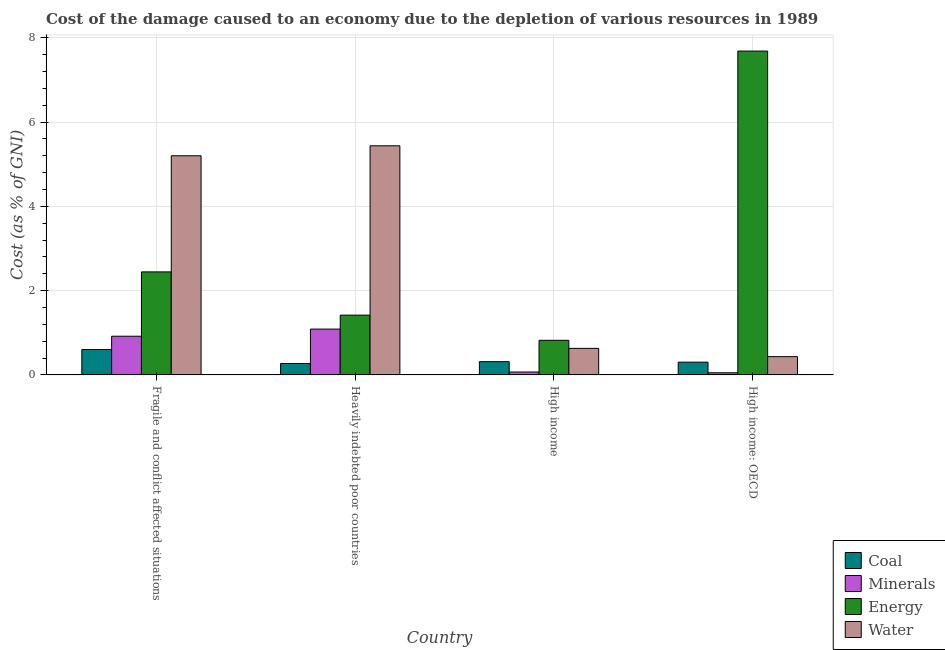How many groups of bars are there?
Provide a short and direct response. 4. Are the number of bars per tick equal to the number of legend labels?
Your answer should be very brief. Yes. Are the number of bars on each tick of the X-axis equal?
Provide a short and direct response. Yes. How many bars are there on the 2nd tick from the left?
Your answer should be very brief. 4. What is the cost of damage due to depletion of water in High income?
Your answer should be very brief. 0.63. Across all countries, what is the maximum cost of damage due to depletion of minerals?
Keep it short and to the point. 1.09. Across all countries, what is the minimum cost of damage due to depletion of coal?
Provide a short and direct response. 0.27. In which country was the cost of damage due to depletion of water maximum?
Ensure brevity in your answer.  Heavily indebted poor countries. In which country was the cost of damage due to depletion of coal minimum?
Your answer should be compact. Heavily indebted poor countries. What is the total cost of damage due to depletion of coal in the graph?
Provide a succinct answer. 1.49. What is the difference between the cost of damage due to depletion of energy in High income and that in High income: OECD?
Your answer should be compact. -6.86. What is the difference between the cost of damage due to depletion of coal in Heavily indebted poor countries and the cost of damage due to depletion of water in Fragile and conflict affected situations?
Your response must be concise. -4.93. What is the average cost of damage due to depletion of energy per country?
Provide a succinct answer. 3.09. What is the difference between the cost of damage due to depletion of water and cost of damage due to depletion of minerals in High income: OECD?
Offer a terse response. 0.38. In how many countries, is the cost of damage due to depletion of water greater than 4.4 %?
Offer a very short reply. 2. What is the ratio of the cost of damage due to depletion of minerals in Fragile and conflict affected situations to that in High income?
Your response must be concise. 13.32. Is the difference between the cost of damage due to depletion of minerals in Fragile and conflict affected situations and High income: OECD greater than the difference between the cost of damage due to depletion of energy in Fragile and conflict affected situations and High income: OECD?
Offer a very short reply. Yes. What is the difference between the highest and the second highest cost of damage due to depletion of energy?
Keep it short and to the point. 5.24. What is the difference between the highest and the lowest cost of damage due to depletion of water?
Your answer should be very brief. 5. Is the sum of the cost of damage due to depletion of energy in Fragile and conflict affected situations and High income greater than the maximum cost of damage due to depletion of minerals across all countries?
Ensure brevity in your answer.  Yes. What does the 2nd bar from the left in Fragile and conflict affected situations represents?
Keep it short and to the point. Minerals. What does the 3rd bar from the right in High income represents?
Your answer should be compact. Minerals. How many bars are there?
Offer a terse response. 16. Are all the bars in the graph horizontal?
Offer a terse response. No. How many countries are there in the graph?
Make the answer very short. 4. What is the difference between two consecutive major ticks on the Y-axis?
Make the answer very short. 2. Does the graph contain grids?
Provide a short and direct response. Yes. Where does the legend appear in the graph?
Keep it short and to the point. Bottom right. How are the legend labels stacked?
Ensure brevity in your answer.  Vertical. What is the title of the graph?
Provide a succinct answer. Cost of the damage caused to an economy due to the depletion of various resources in 1989 . What is the label or title of the X-axis?
Give a very brief answer. Country. What is the label or title of the Y-axis?
Provide a short and direct response. Cost (as % of GNI). What is the Cost (as % of GNI) in Coal in Fragile and conflict affected situations?
Your answer should be compact. 0.6. What is the Cost (as % of GNI) in Minerals in Fragile and conflict affected situations?
Offer a terse response. 0.92. What is the Cost (as % of GNI) of Energy in Fragile and conflict affected situations?
Provide a short and direct response. 2.44. What is the Cost (as % of GNI) in Water in Fragile and conflict affected situations?
Your answer should be very brief. 5.2. What is the Cost (as % of GNI) in Coal in Heavily indebted poor countries?
Your answer should be compact. 0.27. What is the Cost (as % of GNI) of Minerals in Heavily indebted poor countries?
Provide a succinct answer. 1.09. What is the Cost (as % of GNI) of Energy in Heavily indebted poor countries?
Your answer should be very brief. 1.42. What is the Cost (as % of GNI) in Water in Heavily indebted poor countries?
Your answer should be very brief. 5.44. What is the Cost (as % of GNI) in Coal in High income?
Give a very brief answer. 0.31. What is the Cost (as % of GNI) in Minerals in High income?
Ensure brevity in your answer.  0.07. What is the Cost (as % of GNI) of Energy in High income?
Offer a very short reply. 0.82. What is the Cost (as % of GNI) in Water in High income?
Your response must be concise. 0.63. What is the Cost (as % of GNI) in Coal in High income: OECD?
Make the answer very short. 0.3. What is the Cost (as % of GNI) of Minerals in High income: OECD?
Offer a terse response. 0.05. What is the Cost (as % of GNI) of Energy in High income: OECD?
Provide a succinct answer. 7.68. What is the Cost (as % of GNI) in Water in High income: OECD?
Your answer should be compact. 0.43. Across all countries, what is the maximum Cost (as % of GNI) in Coal?
Give a very brief answer. 0.6. Across all countries, what is the maximum Cost (as % of GNI) in Minerals?
Offer a terse response. 1.09. Across all countries, what is the maximum Cost (as % of GNI) of Energy?
Provide a short and direct response. 7.68. Across all countries, what is the maximum Cost (as % of GNI) in Water?
Provide a succinct answer. 5.44. Across all countries, what is the minimum Cost (as % of GNI) in Coal?
Keep it short and to the point. 0.27. Across all countries, what is the minimum Cost (as % of GNI) in Minerals?
Give a very brief answer. 0.05. Across all countries, what is the minimum Cost (as % of GNI) in Energy?
Make the answer very short. 0.82. Across all countries, what is the minimum Cost (as % of GNI) in Water?
Ensure brevity in your answer.  0.43. What is the total Cost (as % of GNI) in Coal in the graph?
Offer a very short reply. 1.49. What is the total Cost (as % of GNI) in Minerals in the graph?
Provide a short and direct response. 2.12. What is the total Cost (as % of GNI) of Energy in the graph?
Ensure brevity in your answer.  12.37. What is the total Cost (as % of GNI) of Water in the graph?
Offer a terse response. 11.7. What is the difference between the Cost (as % of GNI) in Coal in Fragile and conflict affected situations and that in Heavily indebted poor countries?
Keep it short and to the point. 0.33. What is the difference between the Cost (as % of GNI) in Minerals in Fragile and conflict affected situations and that in Heavily indebted poor countries?
Offer a terse response. -0.17. What is the difference between the Cost (as % of GNI) in Energy in Fragile and conflict affected situations and that in Heavily indebted poor countries?
Your response must be concise. 1.03. What is the difference between the Cost (as % of GNI) in Water in Fragile and conflict affected situations and that in Heavily indebted poor countries?
Offer a terse response. -0.24. What is the difference between the Cost (as % of GNI) in Coal in Fragile and conflict affected situations and that in High income?
Your response must be concise. 0.29. What is the difference between the Cost (as % of GNI) in Minerals in Fragile and conflict affected situations and that in High income?
Offer a very short reply. 0.85. What is the difference between the Cost (as % of GNI) in Energy in Fragile and conflict affected situations and that in High income?
Your answer should be compact. 1.62. What is the difference between the Cost (as % of GNI) of Water in Fragile and conflict affected situations and that in High income?
Ensure brevity in your answer.  4.57. What is the difference between the Cost (as % of GNI) in Coal in Fragile and conflict affected situations and that in High income: OECD?
Make the answer very short. 0.3. What is the difference between the Cost (as % of GNI) of Minerals in Fragile and conflict affected situations and that in High income: OECD?
Ensure brevity in your answer.  0.87. What is the difference between the Cost (as % of GNI) in Energy in Fragile and conflict affected situations and that in High income: OECD?
Provide a succinct answer. -5.24. What is the difference between the Cost (as % of GNI) in Water in Fragile and conflict affected situations and that in High income: OECD?
Provide a short and direct response. 4.77. What is the difference between the Cost (as % of GNI) of Coal in Heavily indebted poor countries and that in High income?
Provide a succinct answer. -0.04. What is the difference between the Cost (as % of GNI) in Minerals in Heavily indebted poor countries and that in High income?
Offer a terse response. 1.02. What is the difference between the Cost (as % of GNI) of Energy in Heavily indebted poor countries and that in High income?
Give a very brief answer. 0.6. What is the difference between the Cost (as % of GNI) in Water in Heavily indebted poor countries and that in High income?
Keep it short and to the point. 4.81. What is the difference between the Cost (as % of GNI) of Coal in Heavily indebted poor countries and that in High income: OECD?
Ensure brevity in your answer.  -0.03. What is the difference between the Cost (as % of GNI) of Minerals in Heavily indebted poor countries and that in High income: OECD?
Make the answer very short. 1.04. What is the difference between the Cost (as % of GNI) in Energy in Heavily indebted poor countries and that in High income: OECD?
Provide a short and direct response. -6.26. What is the difference between the Cost (as % of GNI) in Water in Heavily indebted poor countries and that in High income: OECD?
Ensure brevity in your answer.  5. What is the difference between the Cost (as % of GNI) in Coal in High income and that in High income: OECD?
Offer a terse response. 0.01. What is the difference between the Cost (as % of GNI) of Minerals in High income and that in High income: OECD?
Offer a very short reply. 0.02. What is the difference between the Cost (as % of GNI) of Energy in High income and that in High income: OECD?
Your answer should be compact. -6.86. What is the difference between the Cost (as % of GNI) in Water in High income and that in High income: OECD?
Give a very brief answer. 0.2. What is the difference between the Cost (as % of GNI) in Coal in Fragile and conflict affected situations and the Cost (as % of GNI) in Minerals in Heavily indebted poor countries?
Your answer should be very brief. -0.48. What is the difference between the Cost (as % of GNI) in Coal in Fragile and conflict affected situations and the Cost (as % of GNI) in Energy in Heavily indebted poor countries?
Provide a succinct answer. -0.82. What is the difference between the Cost (as % of GNI) of Coal in Fragile and conflict affected situations and the Cost (as % of GNI) of Water in Heavily indebted poor countries?
Keep it short and to the point. -4.83. What is the difference between the Cost (as % of GNI) in Minerals in Fragile and conflict affected situations and the Cost (as % of GNI) in Energy in Heavily indebted poor countries?
Offer a terse response. -0.5. What is the difference between the Cost (as % of GNI) in Minerals in Fragile and conflict affected situations and the Cost (as % of GNI) in Water in Heavily indebted poor countries?
Offer a very short reply. -4.52. What is the difference between the Cost (as % of GNI) in Energy in Fragile and conflict affected situations and the Cost (as % of GNI) in Water in Heavily indebted poor countries?
Offer a terse response. -2.99. What is the difference between the Cost (as % of GNI) of Coal in Fragile and conflict affected situations and the Cost (as % of GNI) of Minerals in High income?
Your answer should be very brief. 0.53. What is the difference between the Cost (as % of GNI) of Coal in Fragile and conflict affected situations and the Cost (as % of GNI) of Energy in High income?
Make the answer very short. -0.22. What is the difference between the Cost (as % of GNI) in Coal in Fragile and conflict affected situations and the Cost (as % of GNI) in Water in High income?
Offer a terse response. -0.03. What is the difference between the Cost (as % of GNI) in Minerals in Fragile and conflict affected situations and the Cost (as % of GNI) in Energy in High income?
Your answer should be compact. 0.1. What is the difference between the Cost (as % of GNI) of Minerals in Fragile and conflict affected situations and the Cost (as % of GNI) of Water in High income?
Provide a succinct answer. 0.29. What is the difference between the Cost (as % of GNI) of Energy in Fragile and conflict affected situations and the Cost (as % of GNI) of Water in High income?
Give a very brief answer. 1.81. What is the difference between the Cost (as % of GNI) in Coal in Fragile and conflict affected situations and the Cost (as % of GNI) in Minerals in High income: OECD?
Make the answer very short. 0.55. What is the difference between the Cost (as % of GNI) of Coal in Fragile and conflict affected situations and the Cost (as % of GNI) of Energy in High income: OECD?
Make the answer very short. -7.08. What is the difference between the Cost (as % of GNI) of Coal in Fragile and conflict affected situations and the Cost (as % of GNI) of Water in High income: OECD?
Offer a terse response. 0.17. What is the difference between the Cost (as % of GNI) in Minerals in Fragile and conflict affected situations and the Cost (as % of GNI) in Energy in High income: OECD?
Offer a terse response. -6.77. What is the difference between the Cost (as % of GNI) in Minerals in Fragile and conflict affected situations and the Cost (as % of GNI) in Water in High income: OECD?
Provide a succinct answer. 0.48. What is the difference between the Cost (as % of GNI) of Energy in Fragile and conflict affected situations and the Cost (as % of GNI) of Water in High income: OECD?
Your answer should be very brief. 2.01. What is the difference between the Cost (as % of GNI) of Coal in Heavily indebted poor countries and the Cost (as % of GNI) of Minerals in High income?
Offer a very short reply. 0.2. What is the difference between the Cost (as % of GNI) of Coal in Heavily indebted poor countries and the Cost (as % of GNI) of Energy in High income?
Offer a terse response. -0.55. What is the difference between the Cost (as % of GNI) of Coal in Heavily indebted poor countries and the Cost (as % of GNI) of Water in High income?
Provide a short and direct response. -0.36. What is the difference between the Cost (as % of GNI) in Minerals in Heavily indebted poor countries and the Cost (as % of GNI) in Energy in High income?
Keep it short and to the point. 0.27. What is the difference between the Cost (as % of GNI) in Minerals in Heavily indebted poor countries and the Cost (as % of GNI) in Water in High income?
Your answer should be very brief. 0.46. What is the difference between the Cost (as % of GNI) in Energy in Heavily indebted poor countries and the Cost (as % of GNI) in Water in High income?
Your answer should be very brief. 0.79. What is the difference between the Cost (as % of GNI) in Coal in Heavily indebted poor countries and the Cost (as % of GNI) in Minerals in High income: OECD?
Give a very brief answer. 0.22. What is the difference between the Cost (as % of GNI) in Coal in Heavily indebted poor countries and the Cost (as % of GNI) in Energy in High income: OECD?
Ensure brevity in your answer.  -7.41. What is the difference between the Cost (as % of GNI) in Coal in Heavily indebted poor countries and the Cost (as % of GNI) in Water in High income: OECD?
Your answer should be very brief. -0.16. What is the difference between the Cost (as % of GNI) of Minerals in Heavily indebted poor countries and the Cost (as % of GNI) of Energy in High income: OECD?
Offer a terse response. -6.6. What is the difference between the Cost (as % of GNI) of Minerals in Heavily indebted poor countries and the Cost (as % of GNI) of Water in High income: OECD?
Your answer should be very brief. 0.65. What is the difference between the Cost (as % of GNI) of Energy in Heavily indebted poor countries and the Cost (as % of GNI) of Water in High income: OECD?
Your answer should be very brief. 0.98. What is the difference between the Cost (as % of GNI) in Coal in High income and the Cost (as % of GNI) in Minerals in High income: OECD?
Ensure brevity in your answer.  0.26. What is the difference between the Cost (as % of GNI) of Coal in High income and the Cost (as % of GNI) of Energy in High income: OECD?
Your answer should be compact. -7.37. What is the difference between the Cost (as % of GNI) in Coal in High income and the Cost (as % of GNI) in Water in High income: OECD?
Offer a very short reply. -0.12. What is the difference between the Cost (as % of GNI) of Minerals in High income and the Cost (as % of GNI) of Energy in High income: OECD?
Make the answer very short. -7.61. What is the difference between the Cost (as % of GNI) of Minerals in High income and the Cost (as % of GNI) of Water in High income: OECD?
Your answer should be compact. -0.36. What is the difference between the Cost (as % of GNI) in Energy in High income and the Cost (as % of GNI) in Water in High income: OECD?
Offer a very short reply. 0.39. What is the average Cost (as % of GNI) of Coal per country?
Offer a terse response. 0.37. What is the average Cost (as % of GNI) of Minerals per country?
Ensure brevity in your answer.  0.53. What is the average Cost (as % of GNI) in Energy per country?
Offer a terse response. 3.09. What is the average Cost (as % of GNI) in Water per country?
Offer a terse response. 2.92. What is the difference between the Cost (as % of GNI) in Coal and Cost (as % of GNI) in Minerals in Fragile and conflict affected situations?
Provide a short and direct response. -0.32. What is the difference between the Cost (as % of GNI) of Coal and Cost (as % of GNI) of Energy in Fragile and conflict affected situations?
Ensure brevity in your answer.  -1.84. What is the difference between the Cost (as % of GNI) of Coal and Cost (as % of GNI) of Water in Fragile and conflict affected situations?
Offer a very short reply. -4.6. What is the difference between the Cost (as % of GNI) in Minerals and Cost (as % of GNI) in Energy in Fragile and conflict affected situations?
Provide a succinct answer. -1.53. What is the difference between the Cost (as % of GNI) of Minerals and Cost (as % of GNI) of Water in Fragile and conflict affected situations?
Offer a very short reply. -4.28. What is the difference between the Cost (as % of GNI) of Energy and Cost (as % of GNI) of Water in Fragile and conflict affected situations?
Give a very brief answer. -2.75. What is the difference between the Cost (as % of GNI) in Coal and Cost (as % of GNI) in Minerals in Heavily indebted poor countries?
Offer a very short reply. -0.82. What is the difference between the Cost (as % of GNI) in Coal and Cost (as % of GNI) in Energy in Heavily indebted poor countries?
Provide a succinct answer. -1.15. What is the difference between the Cost (as % of GNI) of Coal and Cost (as % of GNI) of Water in Heavily indebted poor countries?
Your answer should be very brief. -5.16. What is the difference between the Cost (as % of GNI) of Minerals and Cost (as % of GNI) of Energy in Heavily indebted poor countries?
Offer a very short reply. -0.33. What is the difference between the Cost (as % of GNI) of Minerals and Cost (as % of GNI) of Water in Heavily indebted poor countries?
Provide a short and direct response. -4.35. What is the difference between the Cost (as % of GNI) of Energy and Cost (as % of GNI) of Water in Heavily indebted poor countries?
Your answer should be compact. -4.02. What is the difference between the Cost (as % of GNI) of Coal and Cost (as % of GNI) of Minerals in High income?
Your answer should be very brief. 0.25. What is the difference between the Cost (as % of GNI) of Coal and Cost (as % of GNI) of Energy in High income?
Provide a succinct answer. -0.51. What is the difference between the Cost (as % of GNI) in Coal and Cost (as % of GNI) in Water in High income?
Offer a very short reply. -0.32. What is the difference between the Cost (as % of GNI) of Minerals and Cost (as % of GNI) of Energy in High income?
Offer a very short reply. -0.75. What is the difference between the Cost (as % of GNI) of Minerals and Cost (as % of GNI) of Water in High income?
Your answer should be very brief. -0.56. What is the difference between the Cost (as % of GNI) of Energy and Cost (as % of GNI) of Water in High income?
Make the answer very short. 0.19. What is the difference between the Cost (as % of GNI) in Coal and Cost (as % of GNI) in Minerals in High income: OECD?
Offer a terse response. 0.25. What is the difference between the Cost (as % of GNI) of Coal and Cost (as % of GNI) of Energy in High income: OECD?
Keep it short and to the point. -7.38. What is the difference between the Cost (as % of GNI) in Coal and Cost (as % of GNI) in Water in High income: OECD?
Give a very brief answer. -0.13. What is the difference between the Cost (as % of GNI) in Minerals and Cost (as % of GNI) in Energy in High income: OECD?
Make the answer very short. -7.63. What is the difference between the Cost (as % of GNI) of Minerals and Cost (as % of GNI) of Water in High income: OECD?
Your answer should be compact. -0.38. What is the difference between the Cost (as % of GNI) in Energy and Cost (as % of GNI) in Water in High income: OECD?
Give a very brief answer. 7.25. What is the ratio of the Cost (as % of GNI) of Coal in Fragile and conflict affected situations to that in Heavily indebted poor countries?
Provide a succinct answer. 2.22. What is the ratio of the Cost (as % of GNI) in Minerals in Fragile and conflict affected situations to that in Heavily indebted poor countries?
Provide a succinct answer. 0.84. What is the ratio of the Cost (as % of GNI) in Energy in Fragile and conflict affected situations to that in Heavily indebted poor countries?
Ensure brevity in your answer.  1.72. What is the ratio of the Cost (as % of GNI) of Water in Fragile and conflict affected situations to that in Heavily indebted poor countries?
Offer a very short reply. 0.96. What is the ratio of the Cost (as % of GNI) in Coal in Fragile and conflict affected situations to that in High income?
Ensure brevity in your answer.  1.92. What is the ratio of the Cost (as % of GNI) of Minerals in Fragile and conflict affected situations to that in High income?
Your response must be concise. 13.32. What is the ratio of the Cost (as % of GNI) in Energy in Fragile and conflict affected situations to that in High income?
Ensure brevity in your answer.  2.98. What is the ratio of the Cost (as % of GNI) of Water in Fragile and conflict affected situations to that in High income?
Your answer should be compact. 8.26. What is the ratio of the Cost (as % of GNI) in Coal in Fragile and conflict affected situations to that in High income: OECD?
Offer a terse response. 1.99. What is the ratio of the Cost (as % of GNI) in Minerals in Fragile and conflict affected situations to that in High income: OECD?
Your response must be concise. 18.11. What is the ratio of the Cost (as % of GNI) in Energy in Fragile and conflict affected situations to that in High income: OECD?
Give a very brief answer. 0.32. What is the ratio of the Cost (as % of GNI) in Water in Fragile and conflict affected situations to that in High income: OECD?
Give a very brief answer. 11.98. What is the ratio of the Cost (as % of GNI) of Coal in Heavily indebted poor countries to that in High income?
Your response must be concise. 0.86. What is the ratio of the Cost (as % of GNI) of Minerals in Heavily indebted poor countries to that in High income?
Offer a very short reply. 15.78. What is the ratio of the Cost (as % of GNI) in Energy in Heavily indebted poor countries to that in High income?
Offer a very short reply. 1.73. What is the ratio of the Cost (as % of GNI) of Water in Heavily indebted poor countries to that in High income?
Provide a succinct answer. 8.63. What is the ratio of the Cost (as % of GNI) in Coal in Heavily indebted poor countries to that in High income: OECD?
Offer a very short reply. 0.9. What is the ratio of the Cost (as % of GNI) of Minerals in Heavily indebted poor countries to that in High income: OECD?
Ensure brevity in your answer.  21.46. What is the ratio of the Cost (as % of GNI) of Energy in Heavily indebted poor countries to that in High income: OECD?
Provide a succinct answer. 0.18. What is the ratio of the Cost (as % of GNI) of Water in Heavily indebted poor countries to that in High income: OECD?
Provide a succinct answer. 12.53. What is the ratio of the Cost (as % of GNI) in Coal in High income to that in High income: OECD?
Your response must be concise. 1.04. What is the ratio of the Cost (as % of GNI) of Minerals in High income to that in High income: OECD?
Your answer should be very brief. 1.36. What is the ratio of the Cost (as % of GNI) of Energy in High income to that in High income: OECD?
Your answer should be compact. 0.11. What is the ratio of the Cost (as % of GNI) of Water in High income to that in High income: OECD?
Your answer should be very brief. 1.45. What is the difference between the highest and the second highest Cost (as % of GNI) of Coal?
Your answer should be very brief. 0.29. What is the difference between the highest and the second highest Cost (as % of GNI) in Minerals?
Your answer should be compact. 0.17. What is the difference between the highest and the second highest Cost (as % of GNI) of Energy?
Keep it short and to the point. 5.24. What is the difference between the highest and the second highest Cost (as % of GNI) of Water?
Offer a very short reply. 0.24. What is the difference between the highest and the lowest Cost (as % of GNI) of Coal?
Your answer should be very brief. 0.33. What is the difference between the highest and the lowest Cost (as % of GNI) of Minerals?
Your response must be concise. 1.04. What is the difference between the highest and the lowest Cost (as % of GNI) in Energy?
Offer a terse response. 6.86. What is the difference between the highest and the lowest Cost (as % of GNI) of Water?
Make the answer very short. 5. 